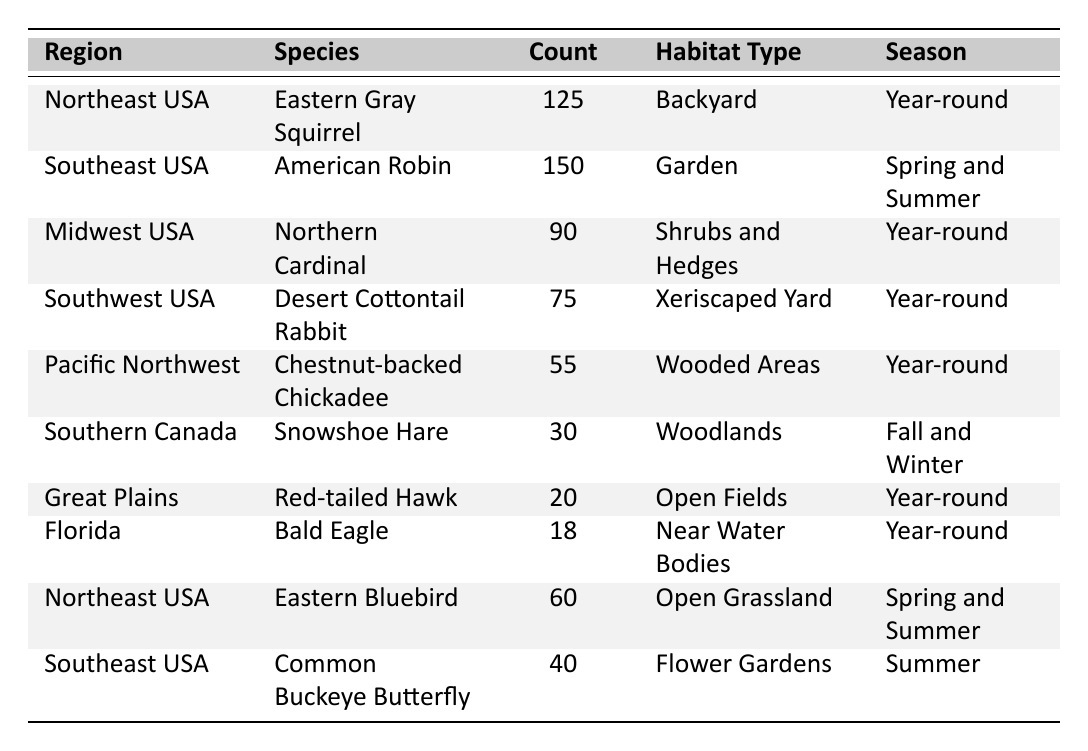What is the most frequently observed wildlife species across all regions? The species with the highest observed count is the American Robin from the Southeast USA, with an observed count of 150.
Answer: American Robin Which region has the least number of wildlife species observed? The region with the least observed count is Florida, with a Bald Eagle observed only 18 times.
Answer: Florida How many species are observed in the Northeast USA? There are 2 species observed in the Northeast USA: Eastern Gray Squirrel (125) and Eastern Bluebird (60).
Answer: 2 What is the total observed count of wildlife species in the Midwest USA? The total observed count in the Midwest USA is the sum of Northern Cardinal (90).
Answer: 90 Is the Snowshoe Hare observed year-round? No, the Snowshoe Hare is not observed year-round; it is only observed in Fall and Winter.
Answer: No Which species observed in the Southeast USA has the lowest observed count? The species is the Common Buckeye Butterfly, which has an observed count of 40.
Answer: Common Buckeye Butterfly What is the average observed count of wildlife species in the Southwest USA and the Pacific Northwest? The observed counts are Desert Cottontail Rabbit (75) and Chestnut-backed Chickadee (55). Their average is (75 + 55) / 2 = 65.
Answer: 65 Which species prefers a habitat type of near water bodies? The Bald Eagle is the species that prefers a habitat type of near water bodies, as noted in the table.
Answer: Bald Eagle What is the total observed count of wildlife species in both the Northeast USA and Southeast USA combined? The combined total for Northeast USA (125 + 60) and Southeast USA (150 + 40) is 375.
Answer: 375 How does the observed count of the Northern Cardinal compare to that of the Red-tailed Hawk? The observed count of Northern Cardinal (90) is significantly higher than that of the Red-tailed Hawk (20), showing a difference of 70.
Answer: 70 